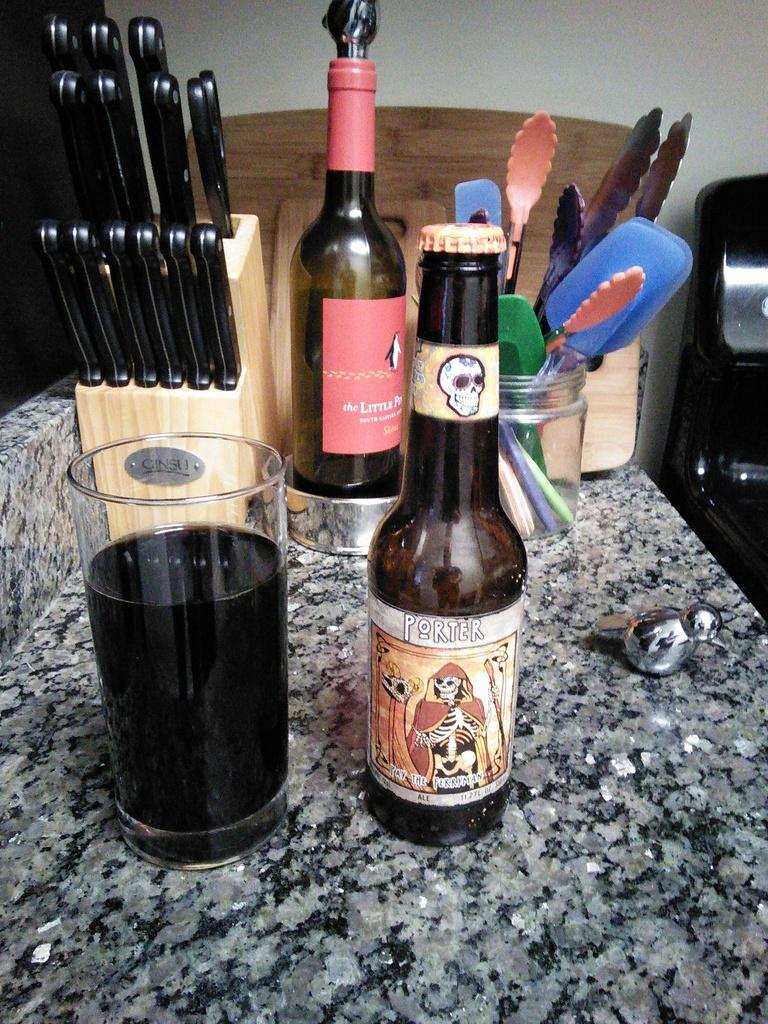<image>
Relay a brief, clear account of the picture shown. A brown bottle of Porter beer next to a tall tumble of beer. 